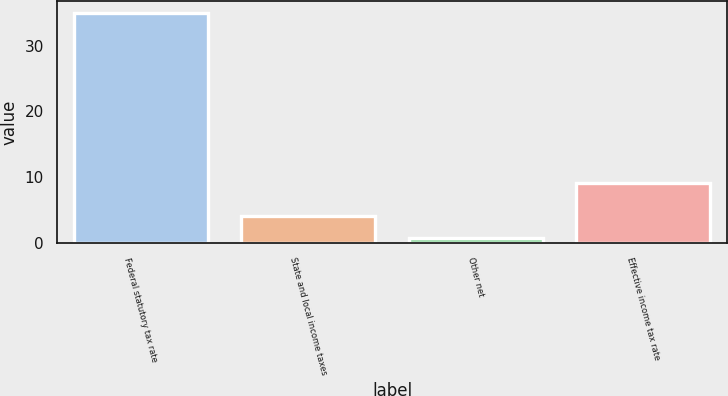<chart> <loc_0><loc_0><loc_500><loc_500><bar_chart><fcel>Federal statutory tax rate<fcel>State and local income taxes<fcel>Other net<fcel>Effective income tax rate<nl><fcel>35<fcel>4.13<fcel>0.7<fcel>9.1<nl></chart> 